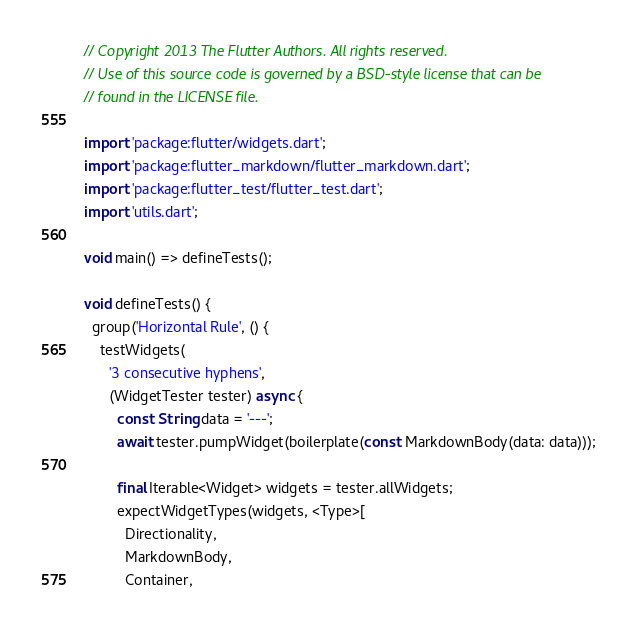Convert code to text. <code><loc_0><loc_0><loc_500><loc_500><_Dart_>// Copyright 2013 The Flutter Authors. All rights reserved.
// Use of this source code is governed by a BSD-style license that can be
// found in the LICENSE file.

import 'package:flutter/widgets.dart';
import 'package:flutter_markdown/flutter_markdown.dart';
import 'package:flutter_test/flutter_test.dart';
import 'utils.dart';

void main() => defineTests();

void defineTests() {
  group('Horizontal Rule', () {
    testWidgets(
      '3 consecutive hyphens',
      (WidgetTester tester) async {
        const String data = '---';
        await tester.pumpWidget(boilerplate(const MarkdownBody(data: data)));

        final Iterable<Widget> widgets = tester.allWidgets;
        expectWidgetTypes(widgets, <Type>[
          Directionality,
          MarkdownBody,
          Container,</code> 